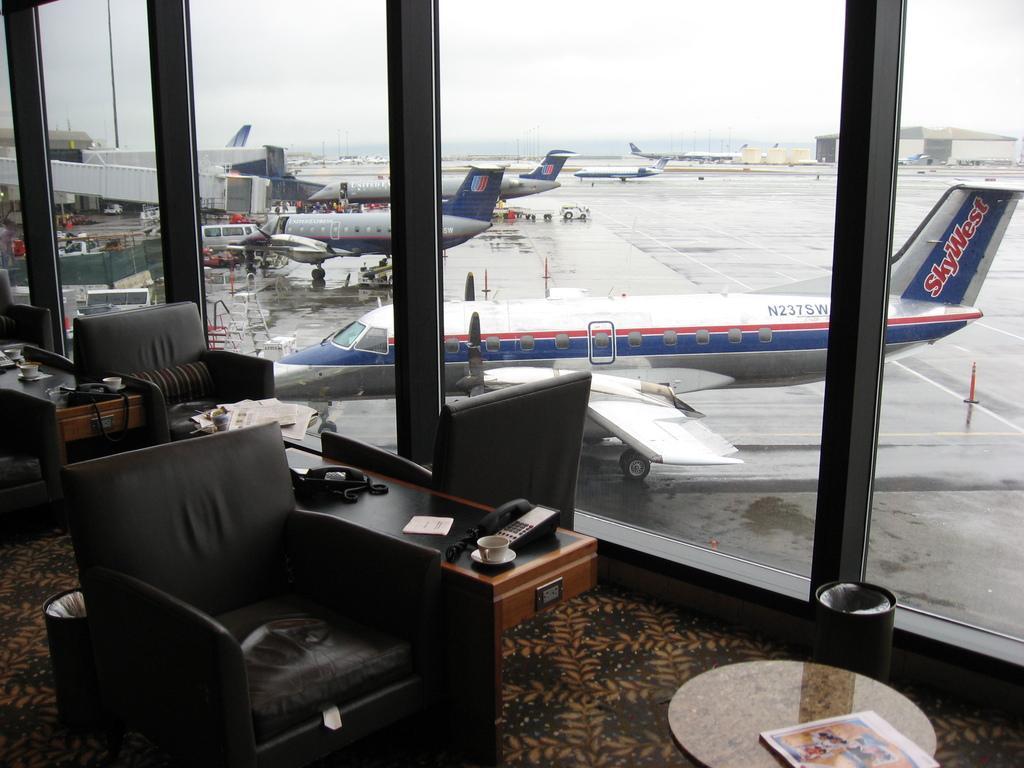Can you describe this image briefly? In this picture we can see chairs, tables on the ground, here we can see cups with saucers, telephones and some objects and in the background we can see airplanes, vehicles, buildings, sky and some objects. 